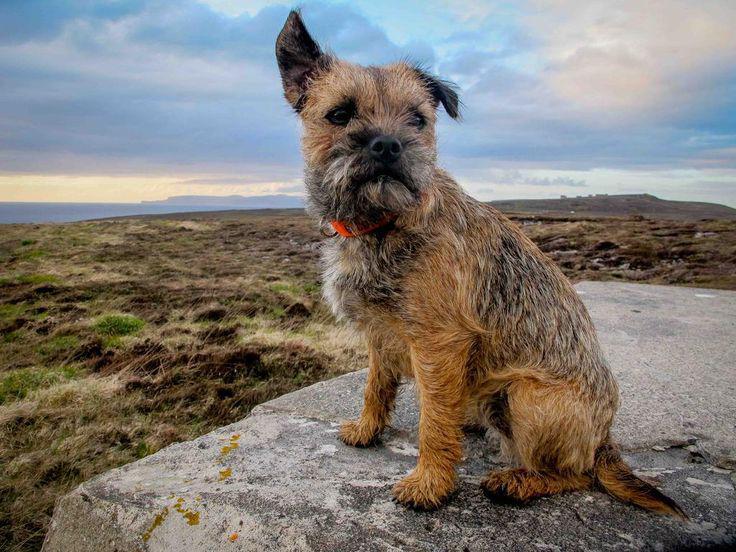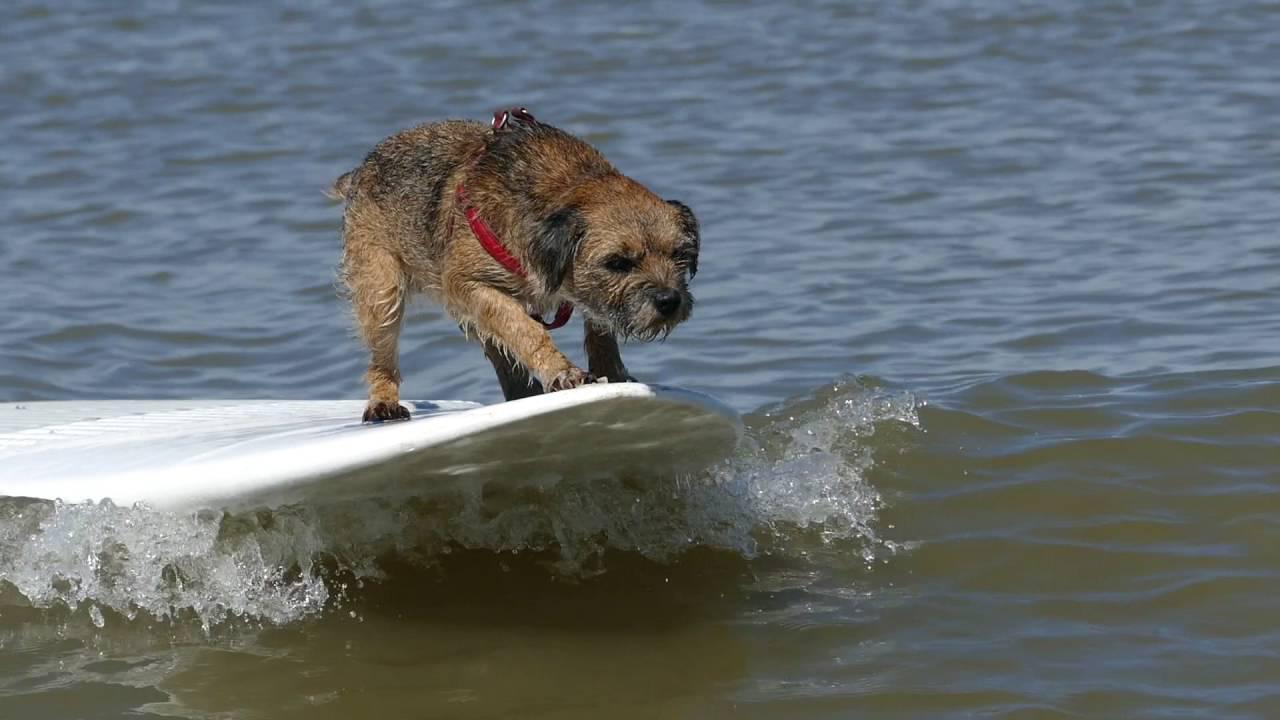The first image is the image on the left, the second image is the image on the right. Examine the images to the left and right. Is the description "dogs are leaping in the water" accurate? Answer yes or no. No. The first image is the image on the left, the second image is the image on the right. Assess this claim about the two images: "Each image contains a wet dog in mid stride over water.". Correct or not? Answer yes or no. No. 